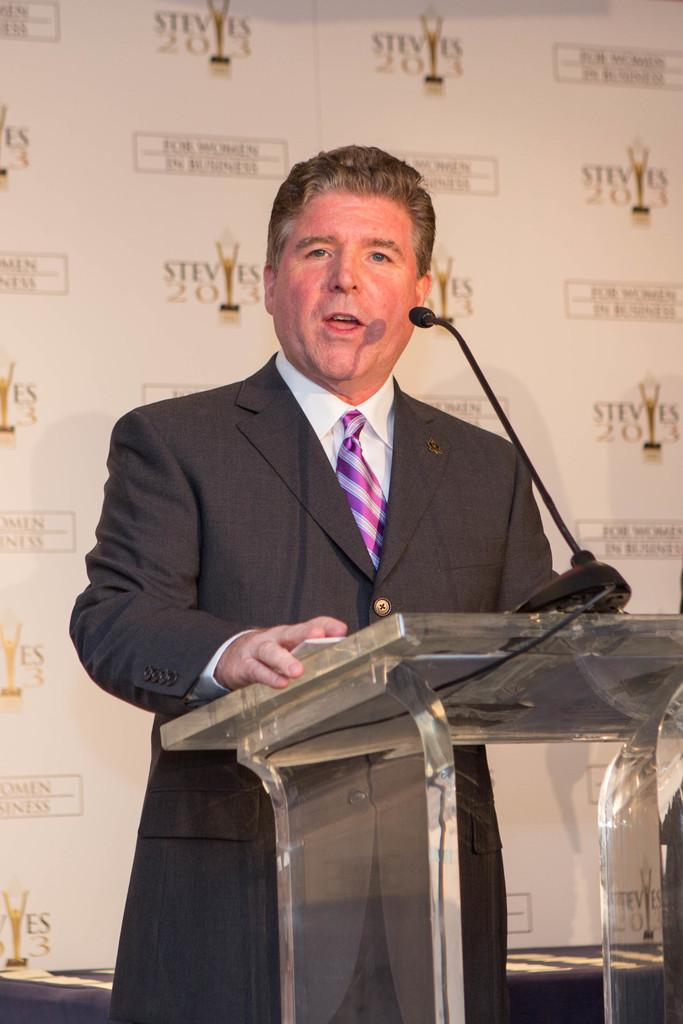Who is the main subject in the image? There is a man in the image. What is the man doing in the image? The man is standing in front of a podium. What is on the podium? There is a microphone on the podium. What is the man wearing in the image? The man is wearing a suit, a shirt, and a tie. What color is the vein on the man's father's arm in the image? There is no father or vein present in the image; it only features a man standing in front of a podium. 